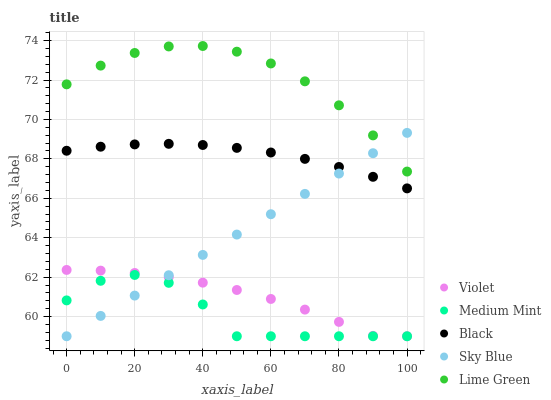Does Medium Mint have the minimum area under the curve?
Answer yes or no. Yes. Does Lime Green have the maximum area under the curve?
Answer yes or no. Yes. Does Sky Blue have the minimum area under the curve?
Answer yes or no. No. Does Sky Blue have the maximum area under the curve?
Answer yes or no. No. Is Sky Blue the smoothest?
Answer yes or no. Yes. Is Medium Mint the roughest?
Answer yes or no. Yes. Is Black the smoothest?
Answer yes or no. No. Is Black the roughest?
Answer yes or no. No. Does Medium Mint have the lowest value?
Answer yes or no. Yes. Does Black have the lowest value?
Answer yes or no. No. Does Lime Green have the highest value?
Answer yes or no. Yes. Does Sky Blue have the highest value?
Answer yes or no. No. Is Black less than Lime Green?
Answer yes or no. Yes. Is Lime Green greater than Violet?
Answer yes or no. Yes. Does Sky Blue intersect Violet?
Answer yes or no. Yes. Is Sky Blue less than Violet?
Answer yes or no. No. Is Sky Blue greater than Violet?
Answer yes or no. No. Does Black intersect Lime Green?
Answer yes or no. No. 